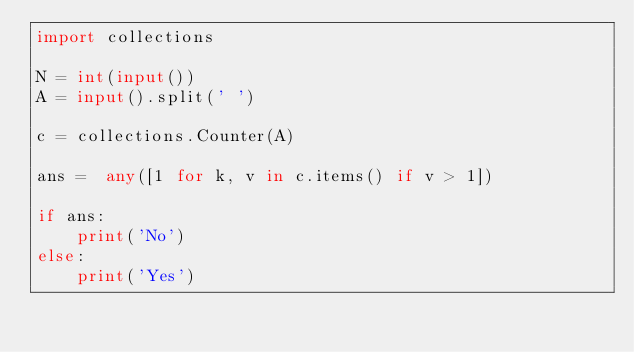Convert code to text. <code><loc_0><loc_0><loc_500><loc_500><_Python_>import collections

N = int(input())
A = input().split(' ')

c = collections.Counter(A)

ans =  any([1 for k, v in c.items() if v > 1])

if ans:
    print('No')
else:
    print('Yes')
</code> 